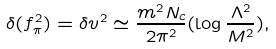<formula> <loc_0><loc_0><loc_500><loc_500>\delta ( f _ { \pi } ^ { 2 } ) = \delta v ^ { 2 } \simeq { \frac { m ^ { 2 } N _ { c } } { 2 \pi ^ { 2 } } } ( \log { \frac { \Lambda ^ { 2 } } { M ^ { 2 } } } ) ,</formula> 